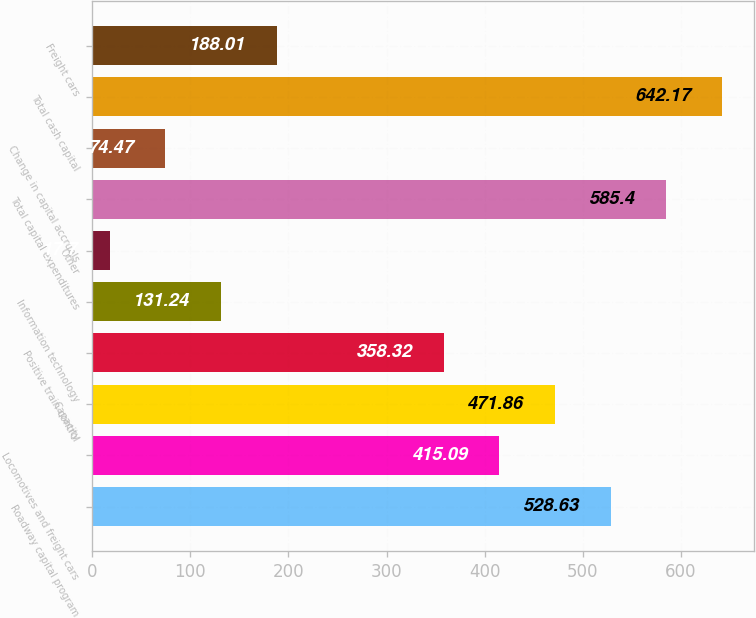Convert chart. <chart><loc_0><loc_0><loc_500><loc_500><bar_chart><fcel>Roadway capital program<fcel>Locomotives and freight cars<fcel>Capacity<fcel>Positive train control<fcel>Information technology<fcel>Other<fcel>Total capital expenditures<fcel>Change in capital accruals<fcel>Total cash capital<fcel>Freight cars<nl><fcel>528.63<fcel>415.09<fcel>471.86<fcel>358.32<fcel>131.24<fcel>17.7<fcel>585.4<fcel>74.47<fcel>642.17<fcel>188.01<nl></chart> 